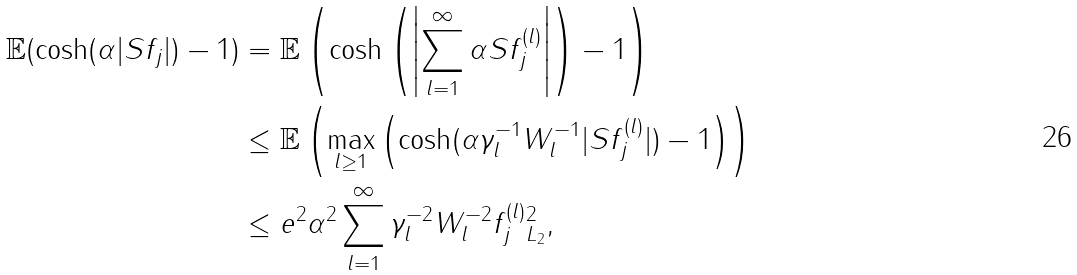<formula> <loc_0><loc_0><loc_500><loc_500>\mathbb { E } ( \cosh ( \alpha | S f _ { j } | ) - 1 ) & = \mathbb { E } \left ( \cosh \left ( \left | \sum _ { l = 1 } ^ { \infty } \alpha S f _ { j } ^ { ( l ) } \right | \right ) - 1 \right ) \\ & \leq \mathbb { E } \left ( \max _ { l \geq 1 } \left ( \cosh ( \alpha \gamma _ { l } ^ { - 1 } W _ { l } ^ { - 1 } | S f _ { j } ^ { ( l ) } | ) - 1 \right ) \right ) \\ & \leq e ^ { 2 } \alpha ^ { 2 } \sum _ { l = 1 } ^ { \infty } \gamma _ { l } ^ { - 2 } W _ { l } ^ { - 2 } \| f _ { j } ^ { ( l ) } \| _ { L _ { 2 } } ^ { 2 } ,</formula> 